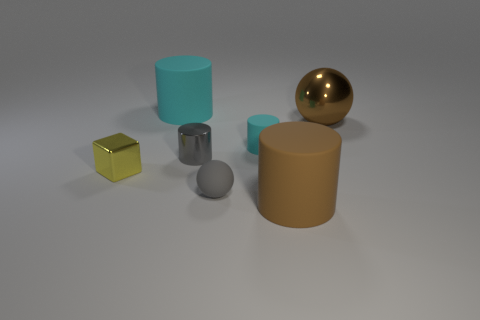Are there any brown things of the same shape as the gray rubber object?
Keep it short and to the point. Yes. What shape is the big cyan object?
Ensure brevity in your answer.  Cylinder. Are there more tiny gray things in front of the gray metallic object than small balls to the right of the large brown shiny thing?
Give a very brief answer. Yes. What number of other objects are the same size as the matte sphere?
Make the answer very short. 3. There is a large object that is on the left side of the large brown metal thing and behind the tiny yellow block; what is its material?
Provide a short and direct response. Rubber. What material is the big brown object that is the same shape as the large cyan rubber thing?
Ensure brevity in your answer.  Rubber. There is a ball to the right of the cylinder in front of the yellow metallic thing; what number of metal cylinders are on the left side of it?
Make the answer very short. 1. Is there any other thing that is the same color as the metal sphere?
Your answer should be very brief. Yes. What number of things are both left of the large cyan rubber cylinder and to the right of the tiny metallic cylinder?
Make the answer very short. 0. Is the size of the cyan object in front of the big cyan rubber cylinder the same as the cylinder that is in front of the small cube?
Offer a very short reply. No. 